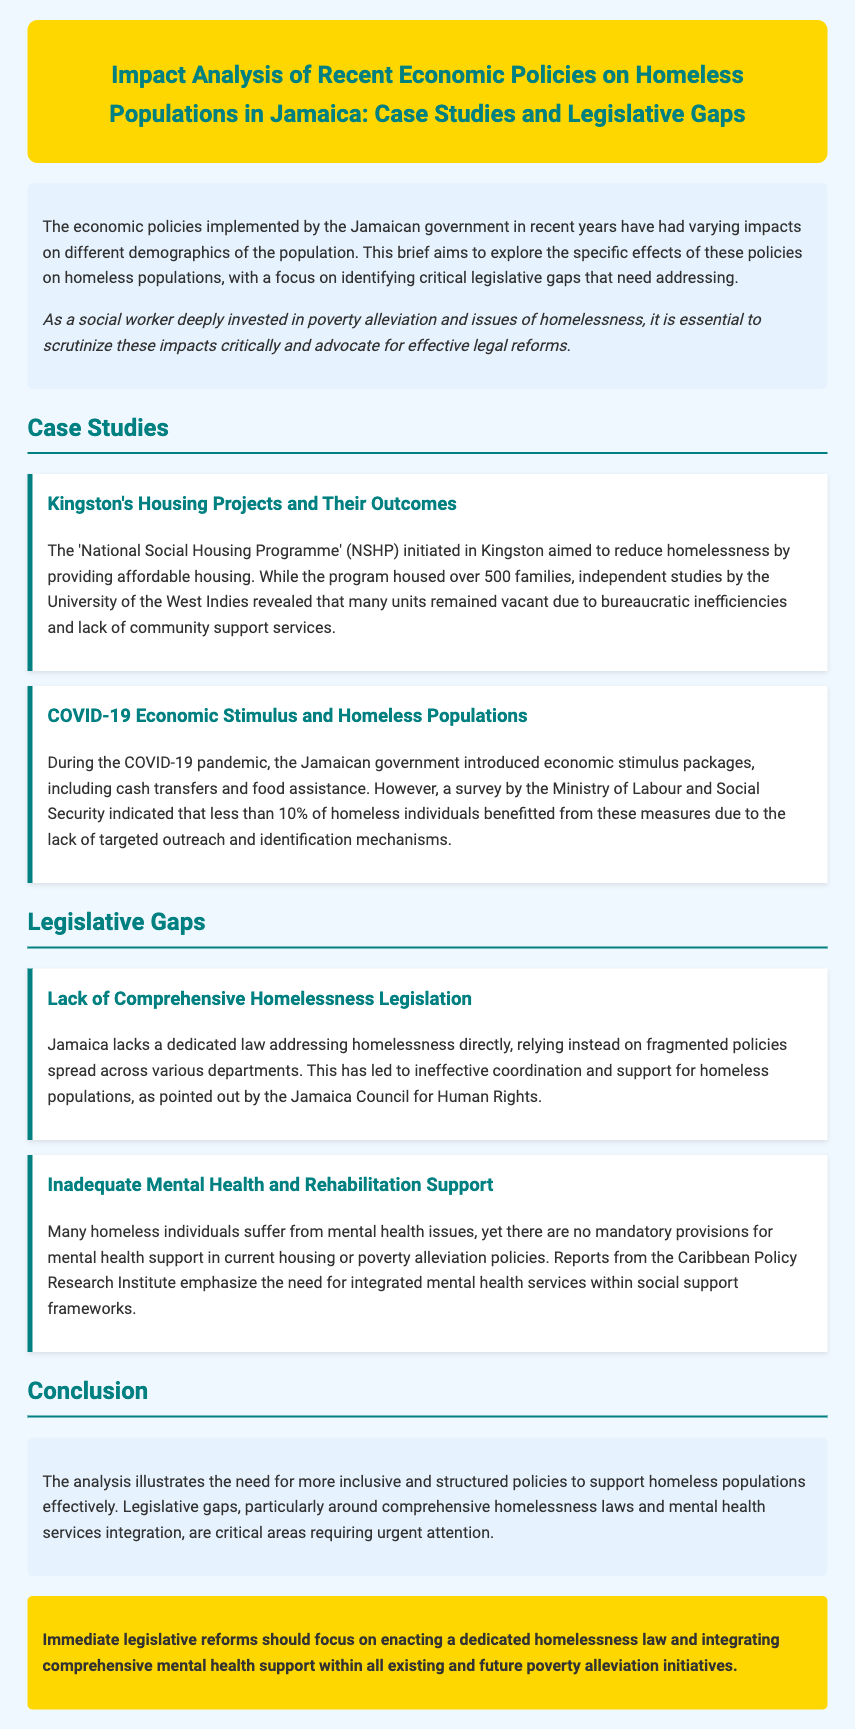What is the title of the document? The title is explicitly stated in the header section of the document.
Answer: Impact Analysis of Recent Economic Policies on Homeless Populations in Jamaica: Case Studies and Legislative Gaps How many families were housed by the National Social Housing Programme? The document specifies that the program housed over 500 families.
Answer: over 500 families What percentage of homeless individuals benefitted from COVID-19 economic stimulus? According to a survey mentioned, less than 10% of homeless individuals benefitted from these measures.
Answer: less than 10% What critical area requires urgent attention according to the conclusion? The conclusion points out specifically that legislative gaps in homelessness laws require urgent attention.
Answer: legislative gaps What organization pointed out the lack of comprehensive homelessness legislation? The Jamaica Council for Human Rights is mentioned as highlighting this issue.
Answer: Jamaica Council for Human Rights What is a suggested focus for immediate legislative reforms? The document suggests enacting a dedicated homelessness law as a focus for immediate legislative reforms.
Answer: enacting a dedicated homelessness law Which economic stimulus measures were introduced during the COVID-19 pandemic? The document lists cash transfers and food assistance as part of the economic stimulus measures.
Answer: cash transfers and food assistance What type of support is lacking in current housing policies according to the case studies? The case studies emphasize the lack of mental health support in current housing policies.
Answer: mental health support 